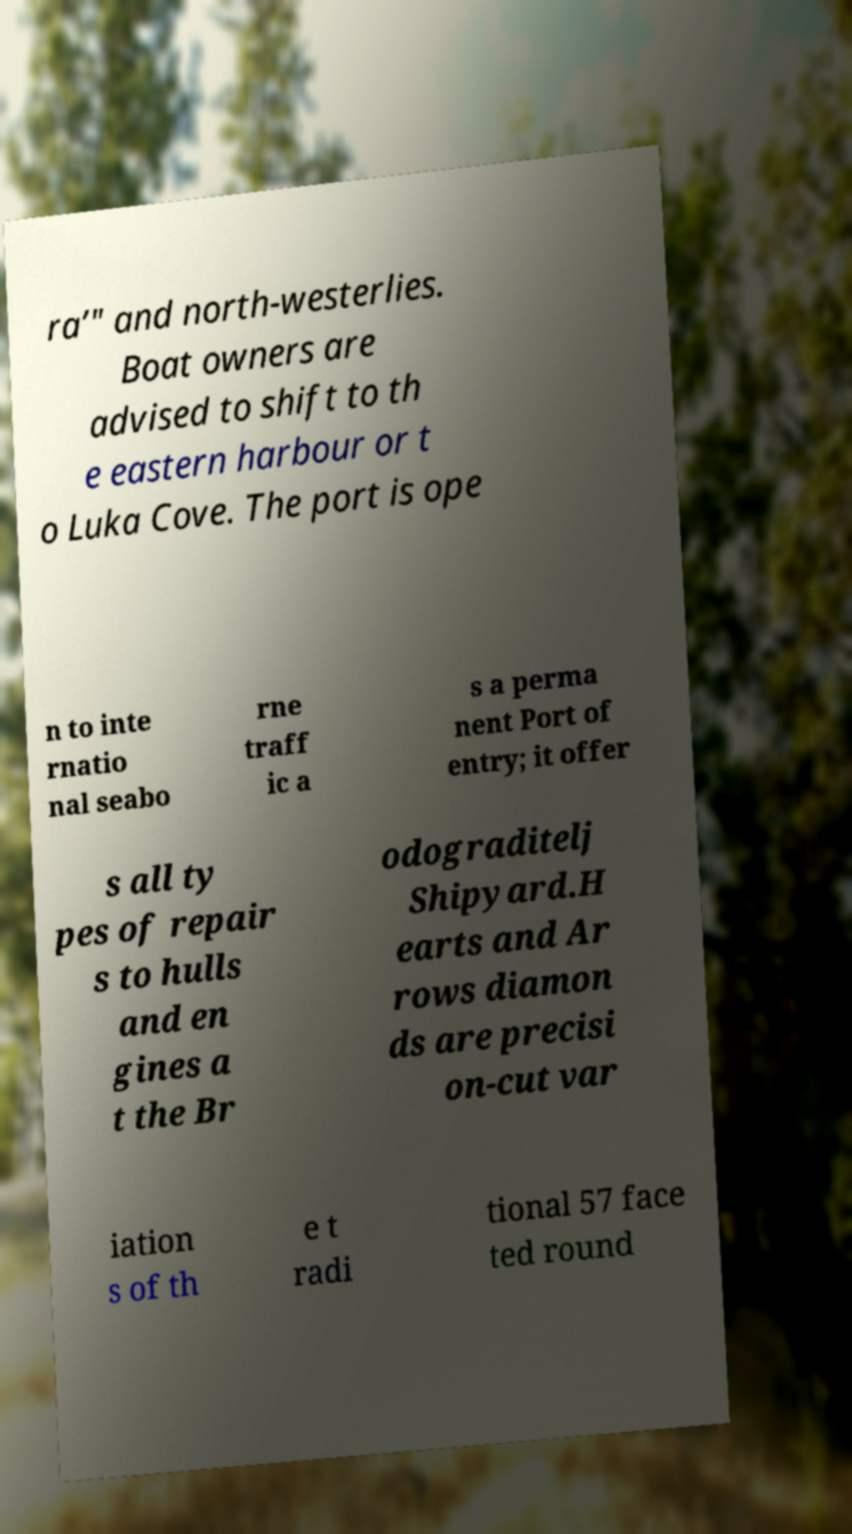I need the written content from this picture converted into text. Can you do that? ra’" and north-westerlies. Boat owners are advised to shift to th e eastern harbour or t o Luka Cove. The port is ope n to inte rnatio nal seabo rne traff ic a s a perma nent Port of entry; it offer s all ty pes of repair s to hulls and en gines a t the Br odograditelj Shipyard.H earts and Ar rows diamon ds are precisi on-cut var iation s of th e t radi tional 57 face ted round 